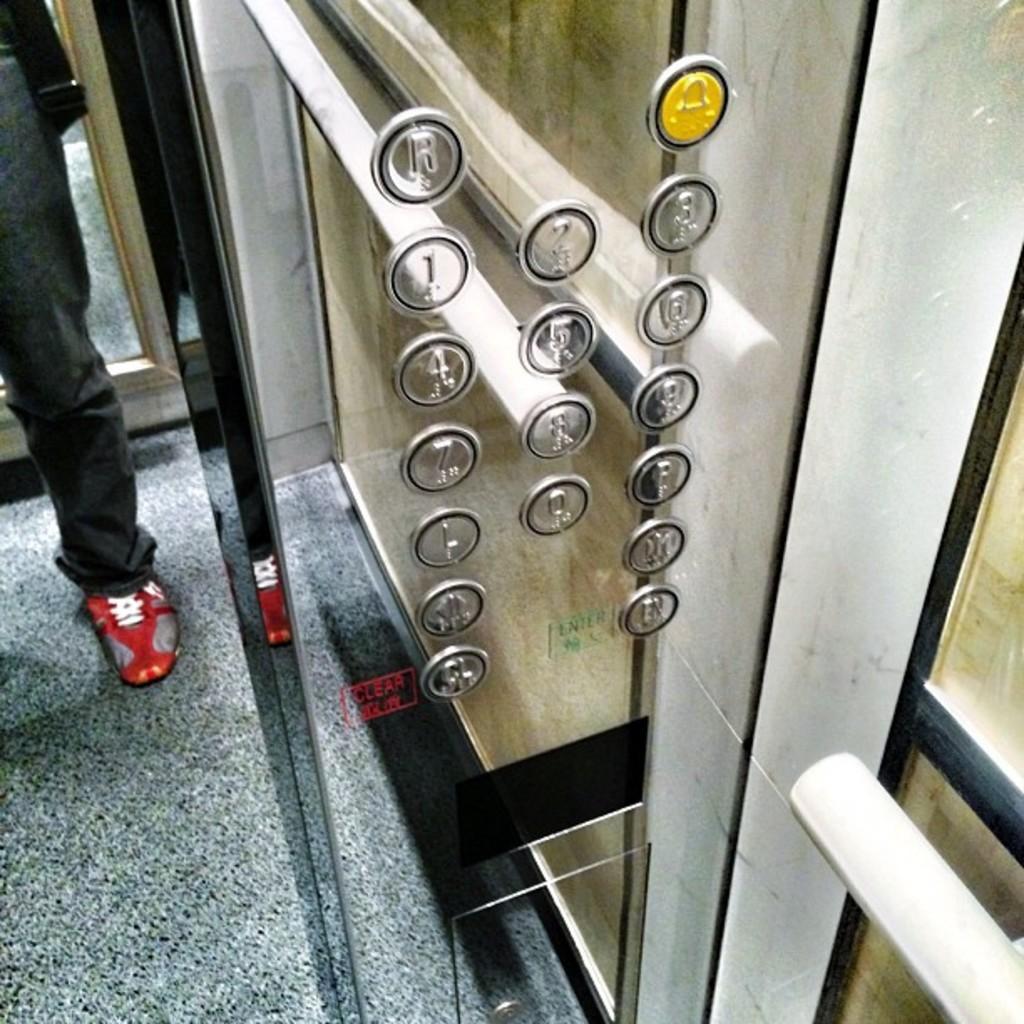Can you describe this image briefly? In the image we can see there is a person standing in the elevator and there are buttons on the elevator. 